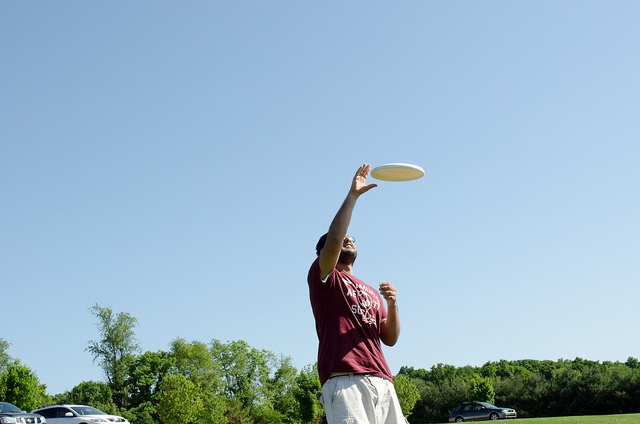Describe the objects in this image and their specific colors. I can see people in darkgray, black, white, and maroon tones, car in darkgray, black, white, and gray tones, car in darkgray, black, gray, and purple tones, frisbee in darkgray, tan, and white tones, and car in darkgray, lightgray, and gray tones in this image. 